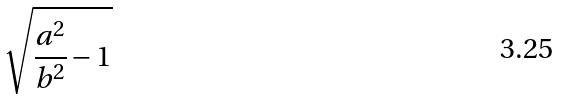<formula> <loc_0><loc_0><loc_500><loc_500>\sqrt { \frac { a ^ { 2 } } { b ^ { 2 } } - 1 }</formula> 